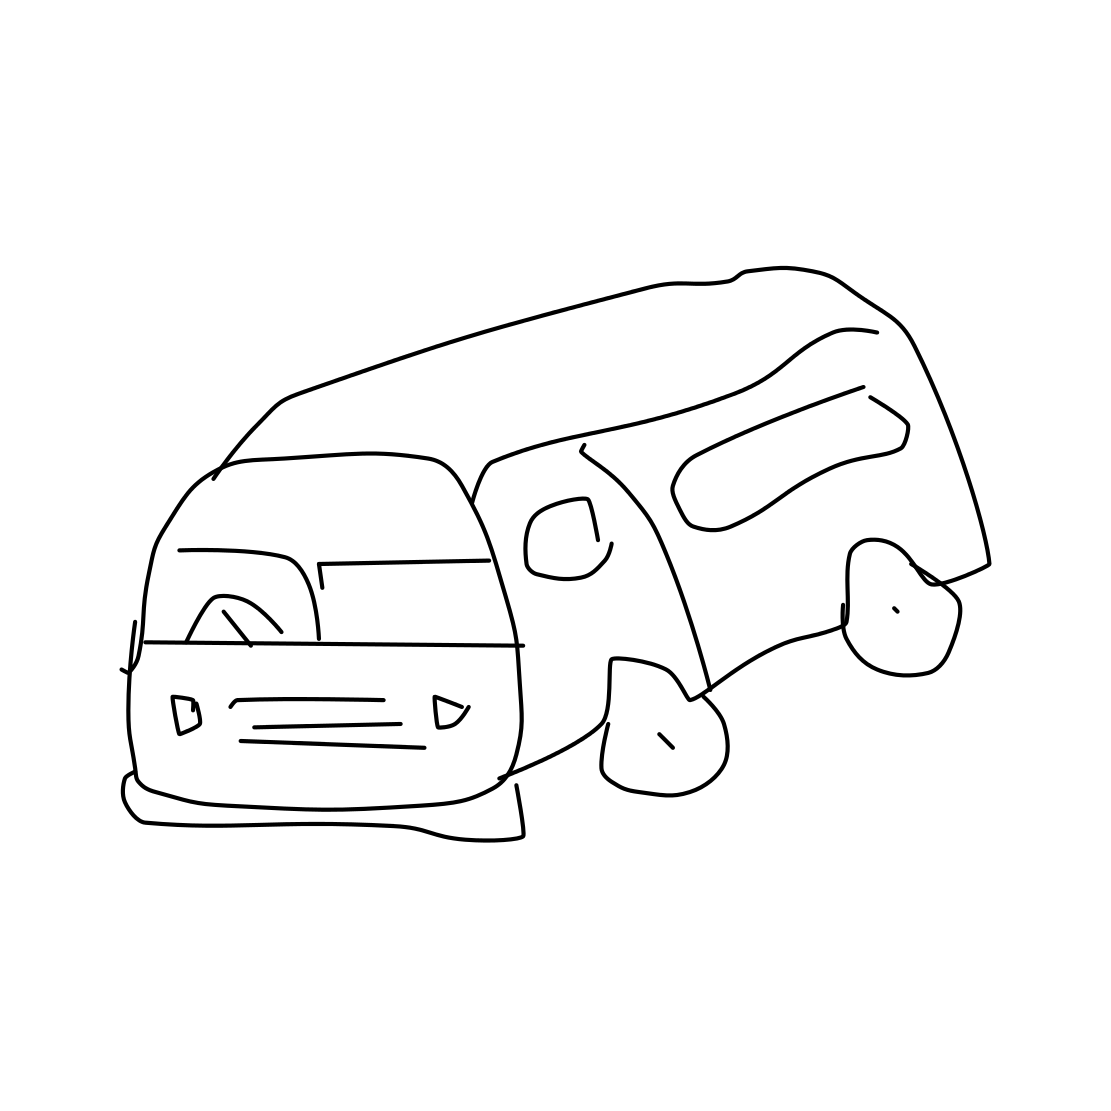Is there a sketchy van in the picture? Indeed, the image does depict a stylized sketch of a van. The simple line drawing captures the essence of a vehicle with discernible features such as windows and wheels, although 'sketchy' in terms of quality and detail. 